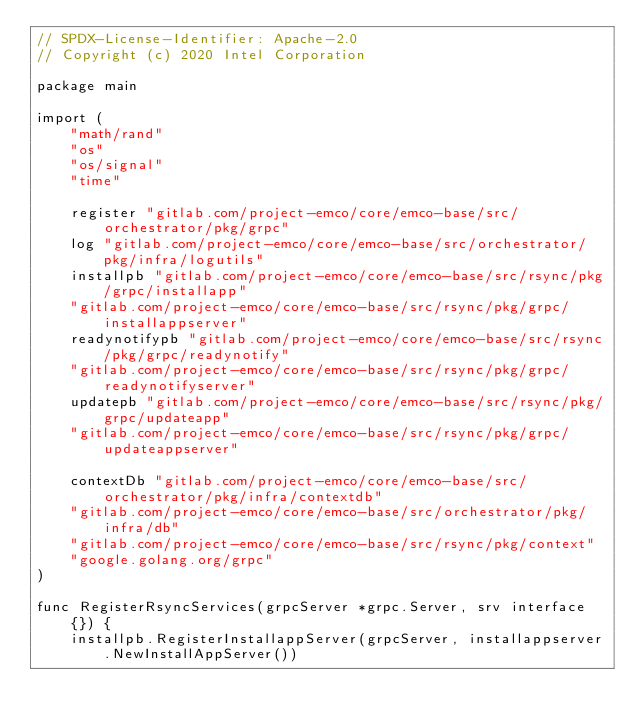Convert code to text. <code><loc_0><loc_0><loc_500><loc_500><_Go_>// SPDX-License-Identifier: Apache-2.0
// Copyright (c) 2020 Intel Corporation

package main

import (
	"math/rand"
	"os"
	"os/signal"
	"time"

	register "gitlab.com/project-emco/core/emco-base/src/orchestrator/pkg/grpc"
	log "gitlab.com/project-emco/core/emco-base/src/orchestrator/pkg/infra/logutils"
	installpb "gitlab.com/project-emco/core/emco-base/src/rsync/pkg/grpc/installapp"
	"gitlab.com/project-emco/core/emco-base/src/rsync/pkg/grpc/installappserver"
	readynotifypb "gitlab.com/project-emco/core/emco-base/src/rsync/pkg/grpc/readynotify"
	"gitlab.com/project-emco/core/emco-base/src/rsync/pkg/grpc/readynotifyserver"
	updatepb "gitlab.com/project-emco/core/emco-base/src/rsync/pkg/grpc/updateapp"
	"gitlab.com/project-emco/core/emco-base/src/rsync/pkg/grpc/updateappserver"

	contextDb "gitlab.com/project-emco/core/emco-base/src/orchestrator/pkg/infra/contextdb"
	"gitlab.com/project-emco/core/emco-base/src/orchestrator/pkg/infra/db"
	"gitlab.com/project-emco/core/emco-base/src/rsync/pkg/context"
	"google.golang.org/grpc"
)

func RegisterRsyncServices(grpcServer *grpc.Server, srv interface{}) {
	installpb.RegisterInstallappServer(grpcServer, installappserver.NewInstallAppServer())</code> 